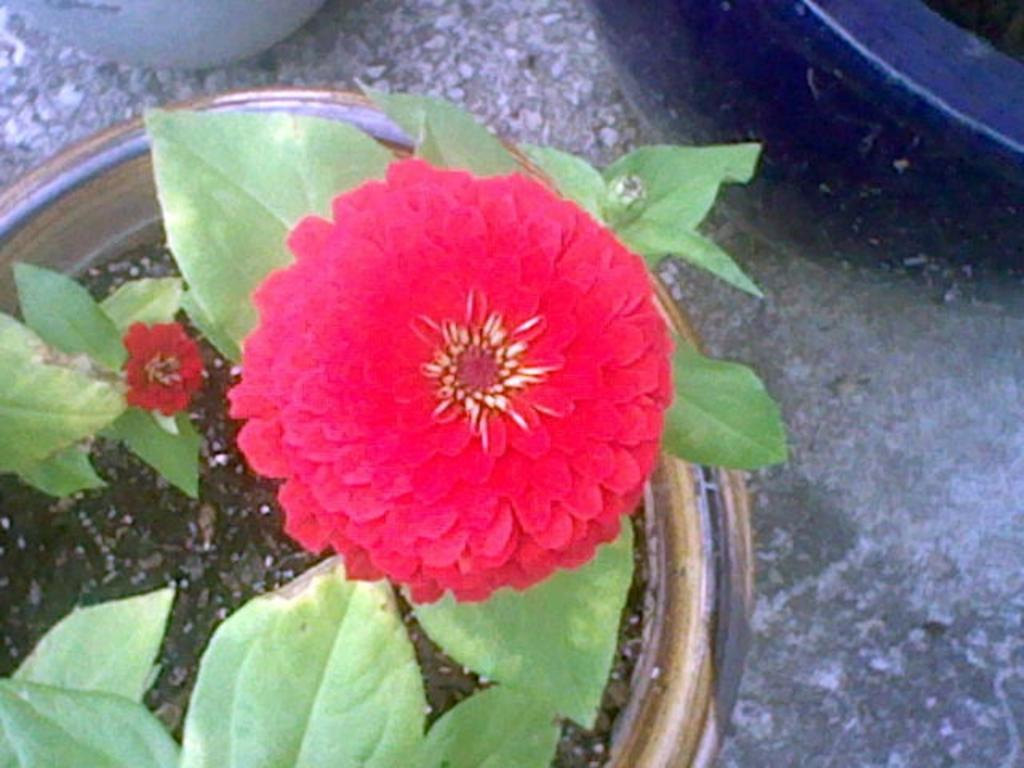What type of plant is in the pot in the image? There is a plant in a pot in the image, but the specific type of plant is not mentioned. However, it has red flowers. What color are the flowers on the plant? The flowers on the plant are red. What can be seen in the top right corner of the image? There is a black object in the top right corner of the image. Where is the white pot located in the image? The white pot is at the top of the image. How is the white pot positioned in the image? The white pot is kept on the floor. What type of cake is being served at the dinner in the image? There is no dinner or cake present in the image; it features a plant in a pot with red flowers, a black object in the top right corner, and a white pot at the top of the image. Is there a basketball game happening in the image? There is no basketball game or any reference to sports in the image. 